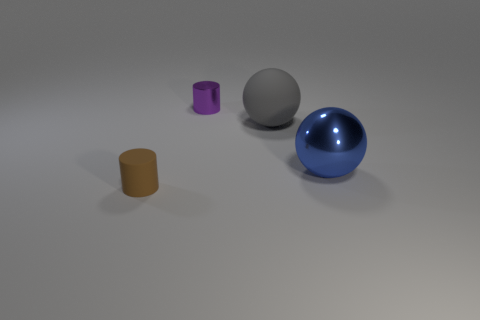Add 3 big cyan matte objects. How many objects exist? 7 Subtract 1 cylinders. How many cylinders are left? 1 Subtract all brown cylinders. How many cylinders are left? 1 Subtract all large brown rubber cylinders. Subtract all big things. How many objects are left? 2 Add 2 tiny brown rubber cylinders. How many tiny brown rubber cylinders are left? 3 Add 4 tiny metallic cylinders. How many tiny metallic cylinders exist? 5 Subtract 0 yellow cylinders. How many objects are left? 4 Subtract all cyan spheres. Subtract all gray blocks. How many spheres are left? 2 Subtract all gray cylinders. How many brown spheres are left? 0 